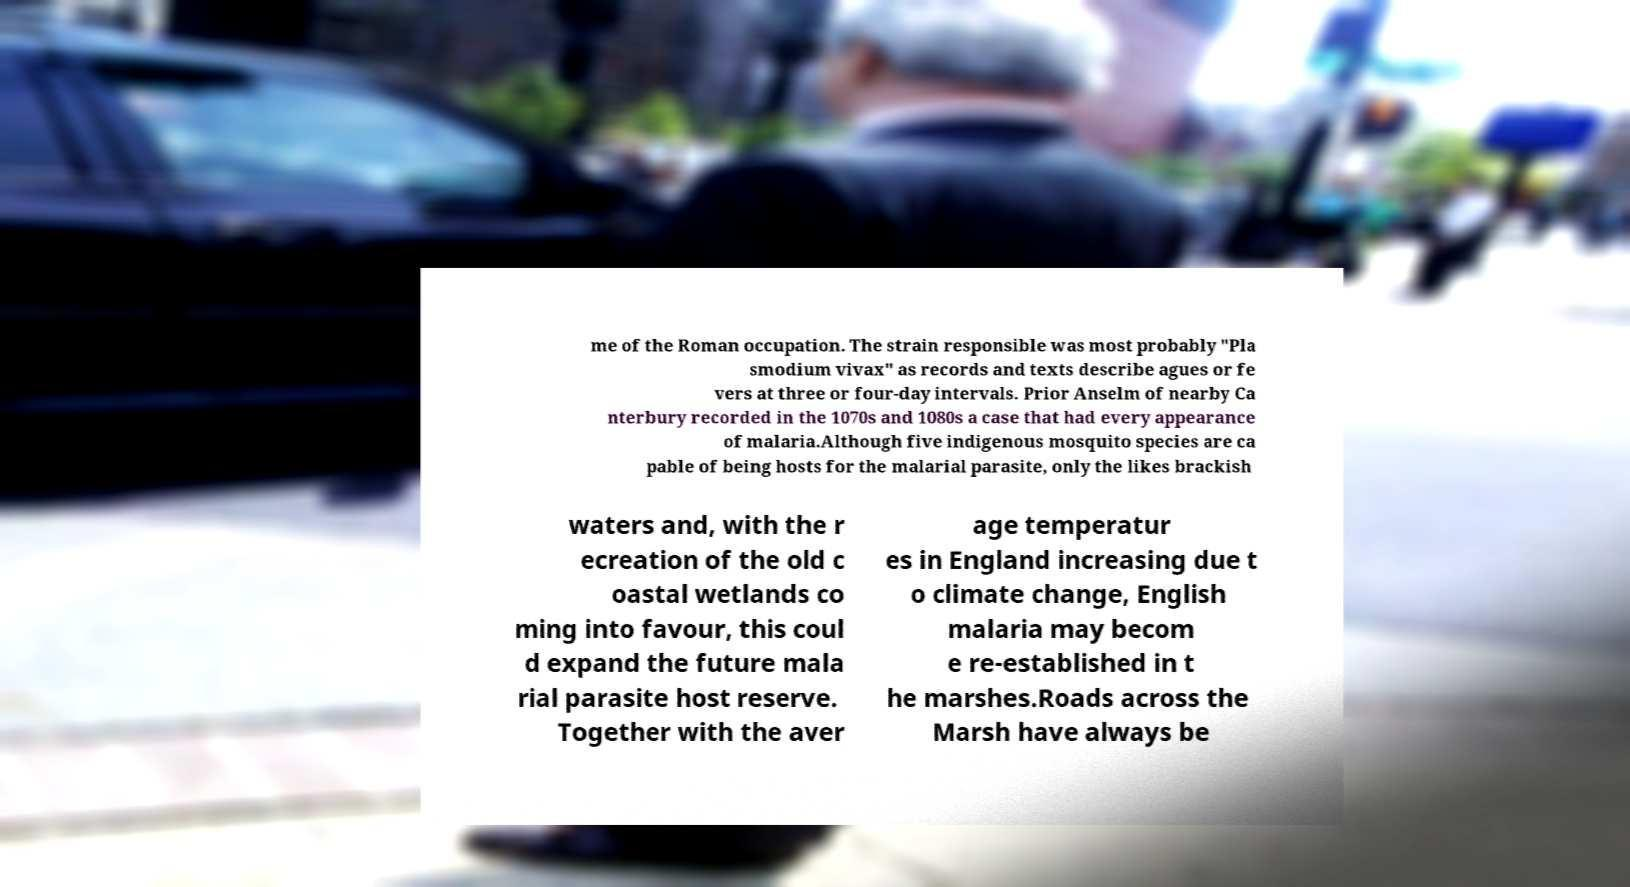Can you accurately transcribe the text from the provided image for me? me of the Roman occupation. The strain responsible was most probably "Pla smodium vivax" as records and texts describe agues or fe vers at three or four-day intervals. Prior Anselm of nearby Ca nterbury recorded in the 1070s and 1080s a case that had every appearance of malaria.Although five indigenous mosquito species are ca pable of being hosts for the malarial parasite, only the likes brackish waters and, with the r ecreation of the old c oastal wetlands co ming into favour, this coul d expand the future mala rial parasite host reserve. Together with the aver age temperatur es in England increasing due t o climate change, English malaria may becom e re-established in t he marshes.Roads across the Marsh have always be 